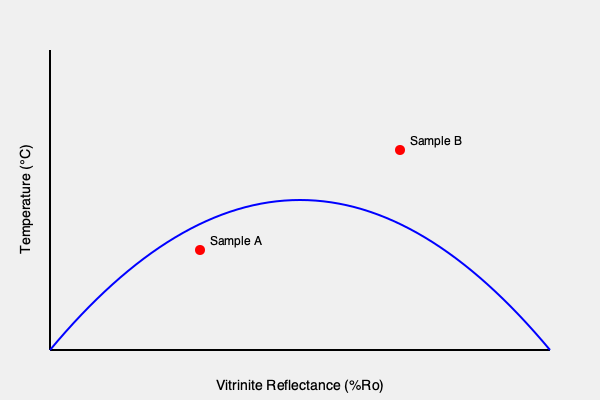As a petroleum geologist, you are analyzing geochemical data to determine the thermal maturity of source rocks in a potential oil field. The graph shows the relationship between vitrinite reflectance (%Ro) and temperature for organic matter in sedimentary rocks. Two samples, A and B, are plotted on the graph. Based on this information, which sample represents a more thermally mature source rock, and what is the approximate temperature difference between the two samples? To answer this question, we need to understand the relationship between vitrinite reflectance, temperature, and thermal maturity, then analyze the graph to compare the two samples.

Step 1: Understand the relationship
- Vitrinite reflectance (%Ro) is a measure of thermal maturity in source rocks.
- Higher %Ro values indicate higher thermal maturity.
- The curve shows that as temperature increases, %Ro also increases.

Step 2: Analyze Sample A
- Sample A has a lower %Ro value (x-axis position is further left).
- Its corresponding temperature on the y-axis is lower.

Step 3: Analyze Sample B
- Sample B has a higher %Ro value (x-axis position is further right).
- Its corresponding temperature on the y-axis is higher.

Step 4: Compare thermal maturity
- Since Sample B has a higher %Ro value, it represents a more thermally mature source rock.

Step 5: Estimate temperature difference
- Visually estimate the y-axis values for both samples.
- Sample A: approximately 180°C
- Sample B: approximately 280°C
- Temperature difference: 280°C - 180°C = 100°C

Therefore, Sample B represents a more thermally mature source rock, and the approximate temperature difference between the two samples is 100°C.
Answer: Sample B; 100°C 